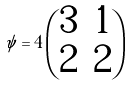Convert formula to latex. <formula><loc_0><loc_0><loc_500><loc_500>\psi = 4 \begin{pmatrix} 3 & 1 \\ 2 & 2 \end{pmatrix}</formula> 